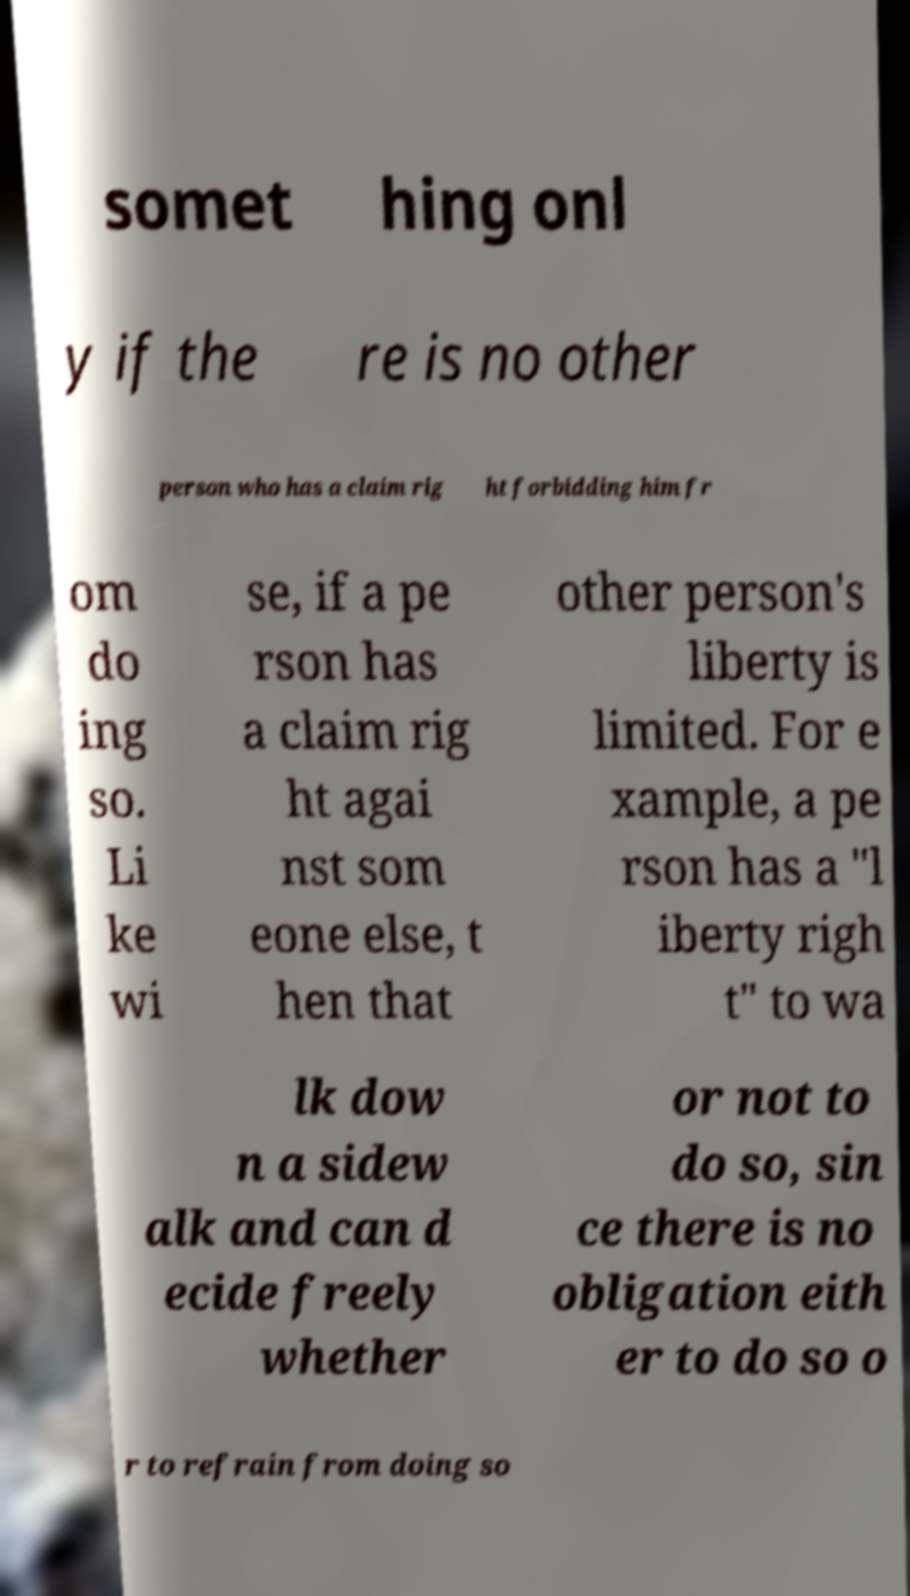There's text embedded in this image that I need extracted. Can you transcribe it verbatim? somet hing onl y if the re is no other person who has a claim rig ht forbidding him fr om do ing so. Li ke wi se, if a pe rson has a claim rig ht agai nst som eone else, t hen that other person's liberty is limited. For e xample, a pe rson has a "l iberty righ t" to wa lk dow n a sidew alk and can d ecide freely whether or not to do so, sin ce there is no obligation eith er to do so o r to refrain from doing so 